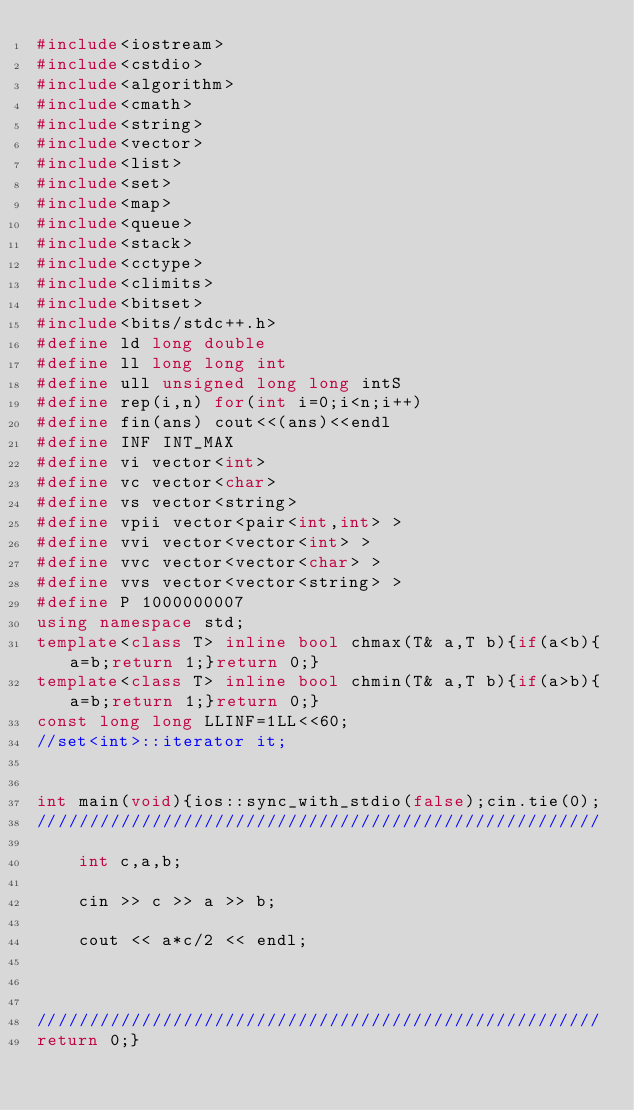Convert code to text. <code><loc_0><loc_0><loc_500><loc_500><_C++_>#include<iostream>
#include<cstdio>
#include<algorithm>
#include<cmath>
#include<string>
#include<vector>
#include<list>
#include<set>
#include<map>
#include<queue>
#include<stack>
#include<cctype>
#include<climits>
#include<bitset>
#include<bits/stdc++.h>
#define ld long double
#define ll long long int
#define ull unsigned long long intS
#define rep(i,n) for(int i=0;i<n;i++)
#define fin(ans) cout<<(ans)<<endl
#define INF INT_MAX
#define vi vector<int>
#define vc vector<char>
#define vs vector<string>
#define vpii vector<pair<int,int> >
#define vvi vector<vector<int> >
#define vvc vector<vector<char> >
#define vvs vector<vector<string> >
#define P 1000000007
using namespace std;
template<class T> inline bool chmax(T& a,T b){if(a<b){a=b;return 1;}return 0;}
template<class T> inline bool chmin(T& a,T b){if(a>b){a=b;return 1;}return 0;}
const long long LLINF=1LL<<60;
//set<int>::iterator it;


int main(void){ios::sync_with_stdio(false);cin.tie(0);
//////////////////////////////////////////////////////
    
    int c,a,b;
    
    cin >> c >> a >> b;
    
    cout << a*c/2 << endl;
    
    
    
//////////////////////////////////////////////////////
return 0;}</code> 